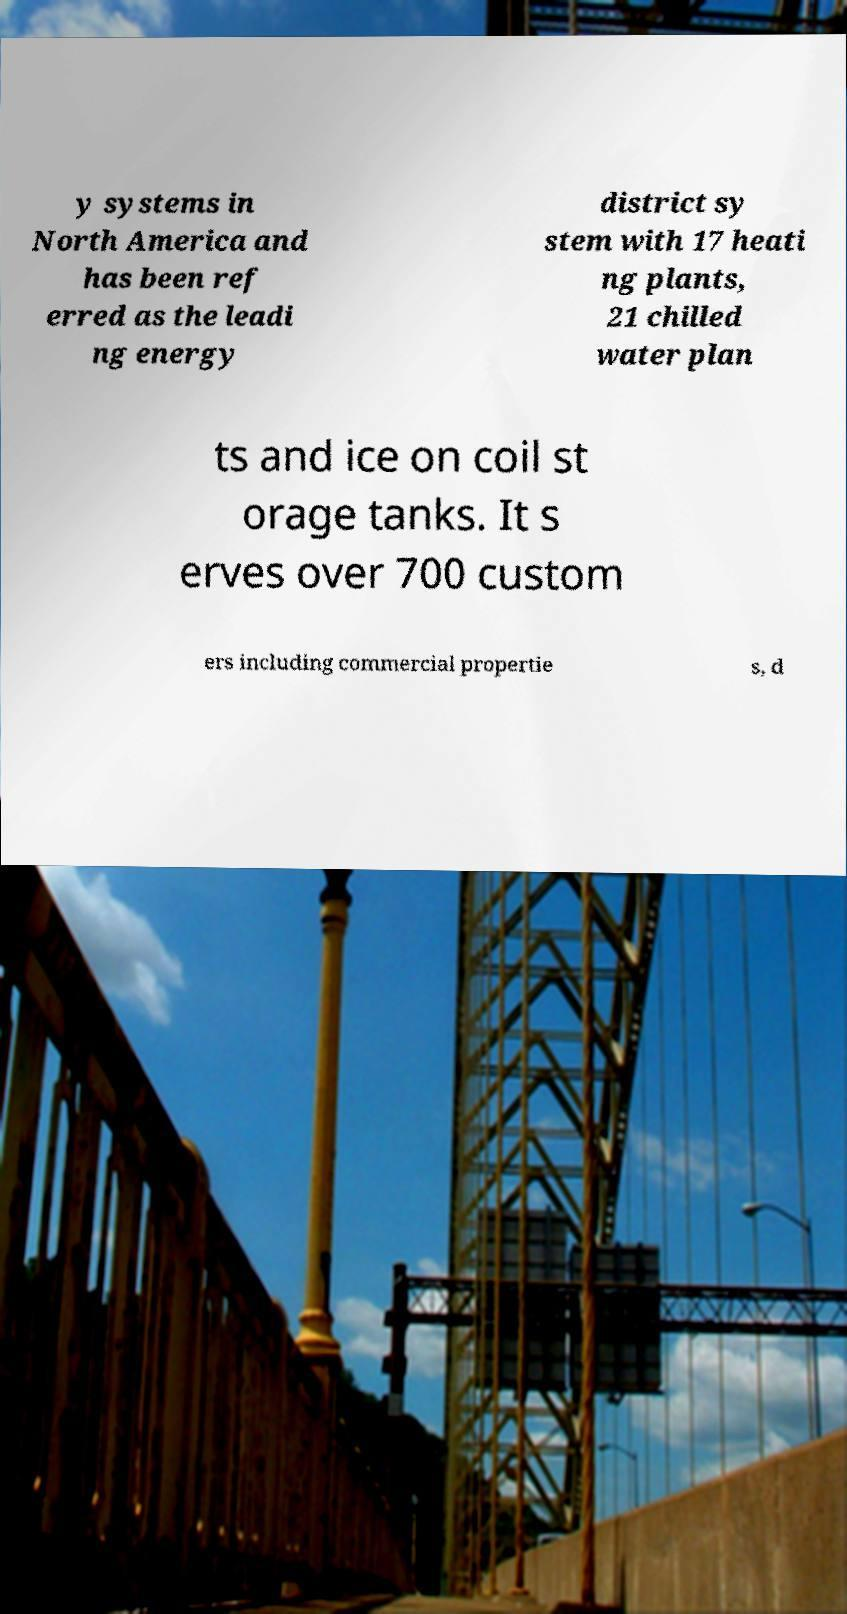Could you extract and type out the text from this image? y systems in North America and has been ref erred as the leadi ng energy district sy stem with 17 heati ng plants, 21 chilled water plan ts and ice on coil st orage tanks. It s erves over 700 custom ers including commercial propertie s, d 